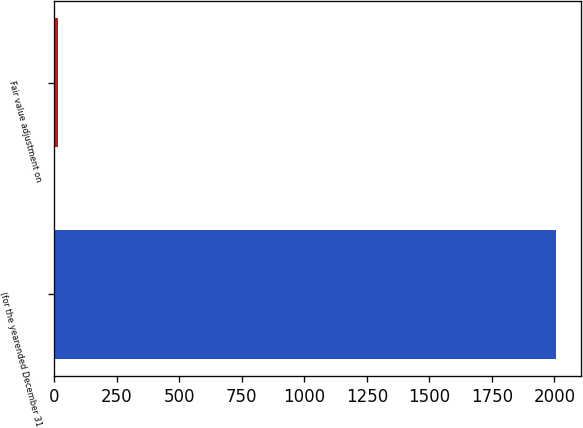<chart> <loc_0><loc_0><loc_500><loc_500><bar_chart><fcel>(for the yearended December 31<fcel>Fair value adjustment on<nl><fcel>2006<fcel>16<nl></chart> 